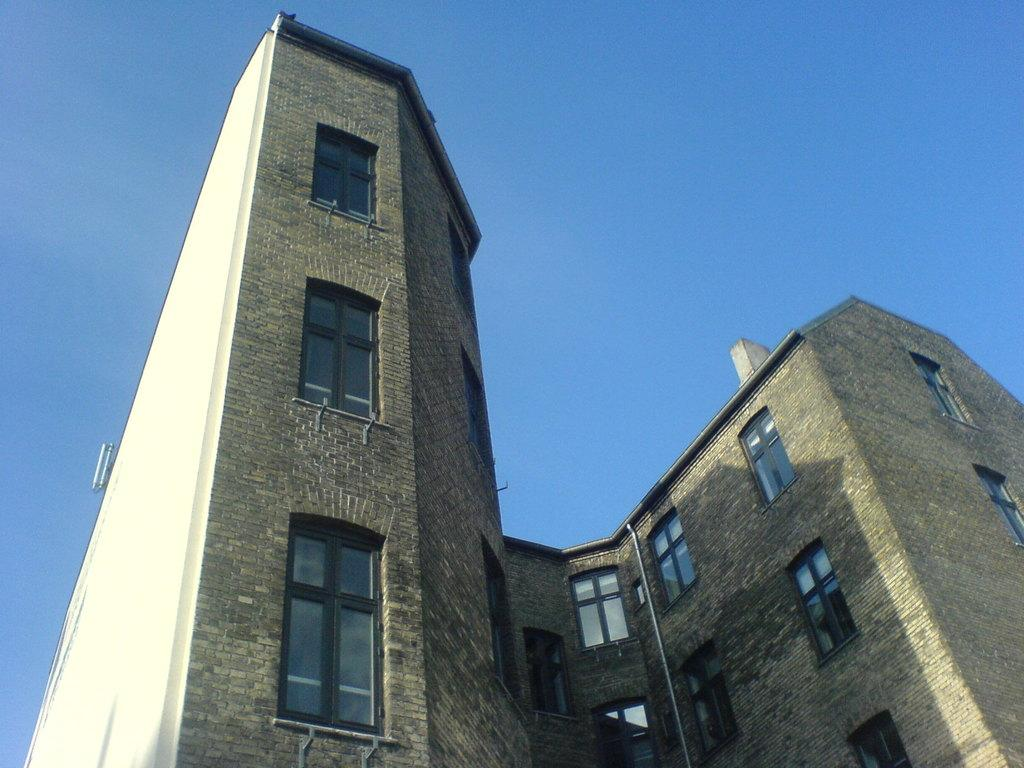What type of structure is present in the image? There is a building in the image. What features can be seen on the building? The building has doors and windows. What is visible at the top of the image? The sky is visible at the top of the image. What type of glass is being offered to the fictional character in the image? There is no glass or fictional character present in the image. 